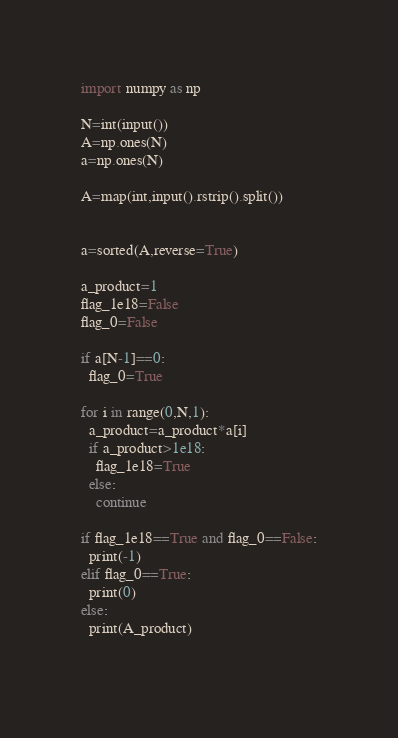<code> <loc_0><loc_0><loc_500><loc_500><_Python_>import numpy as np

N=int(input())
A=np.ones(N)
a=np.ones(N)

A=map(int,input().rstrip().split())


a=sorted(A,reverse=True)

a_product=1
flag_1e18=False
flag_0=False

if a[N-1]==0:
  flag_0=True

for i in range(0,N,1):
  a_product=a_product*a[i]
  if a_product>1e18:
    flag_1e18=True
  else:
    continue
    
if flag_1e18==True and flag_0==False:
  print(-1)
elif flag_0==True:
  print(0)
else:
  print(A_product)
  
</code> 